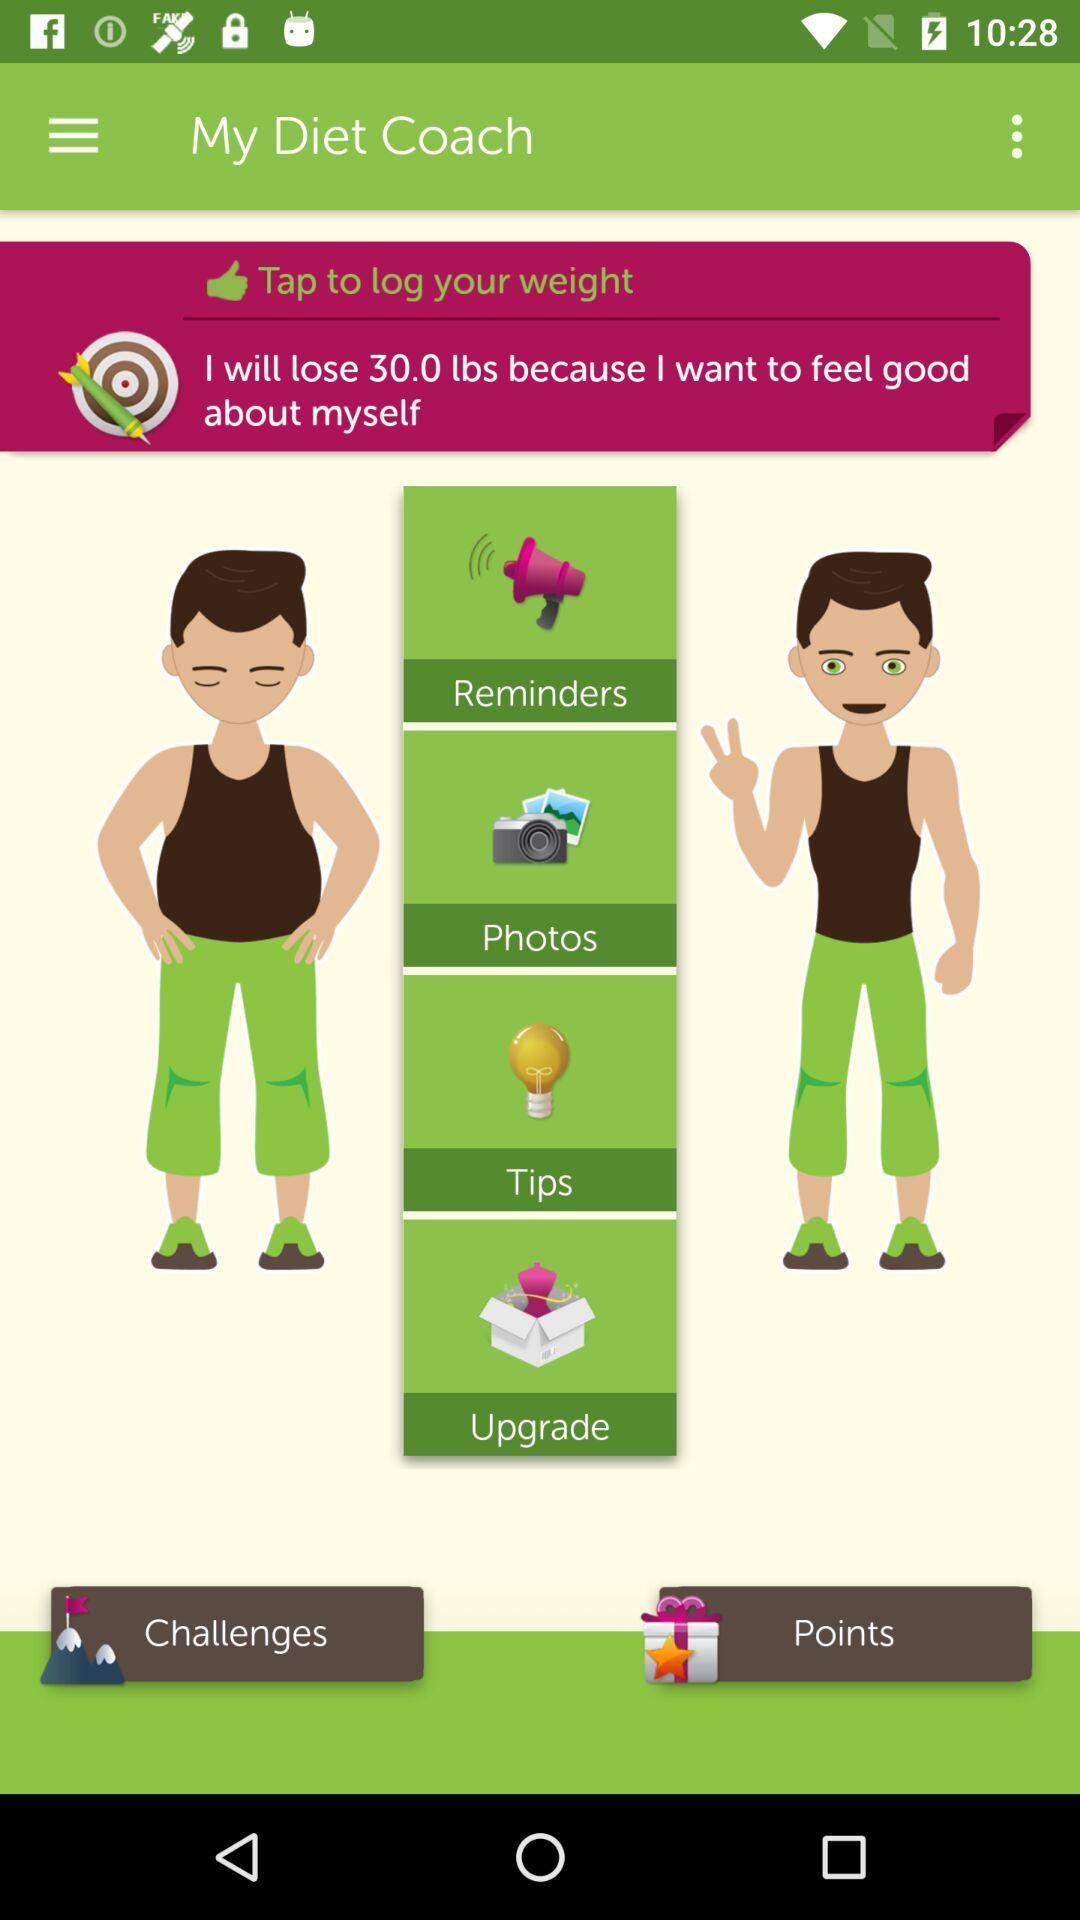How many more lbs do I need to lose to reach my goal?
Answer the question using a single word or phrase. 30.0 